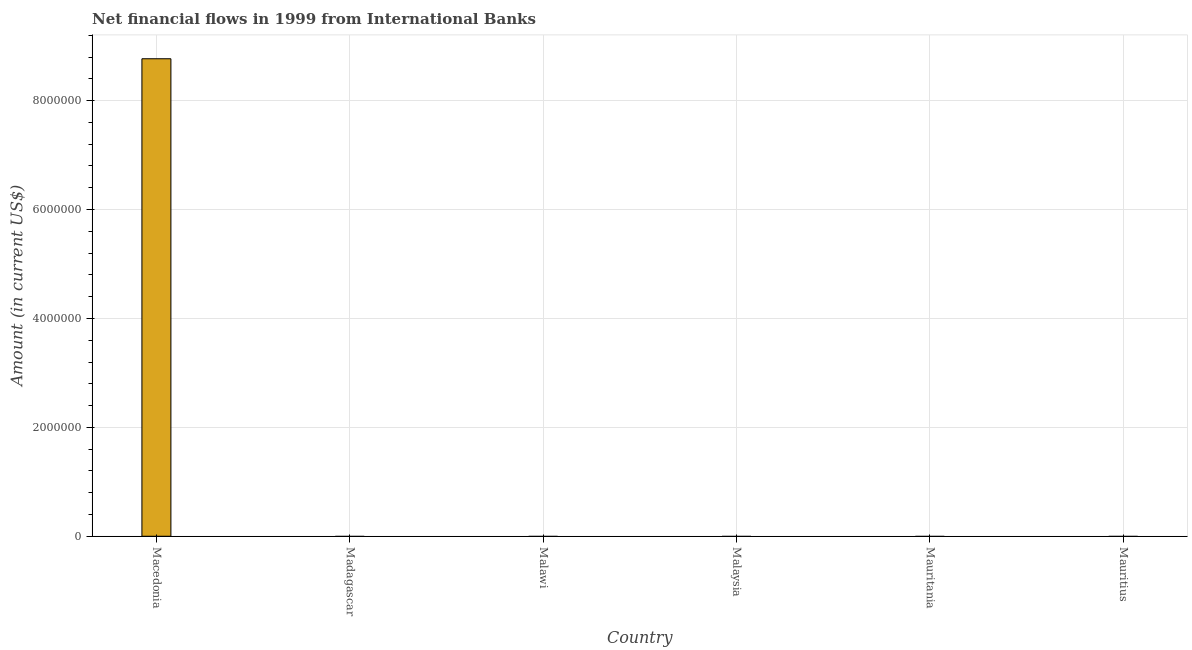What is the title of the graph?
Offer a terse response. Net financial flows in 1999 from International Banks. What is the label or title of the X-axis?
Offer a terse response. Country. Across all countries, what is the maximum net financial flows from ibrd?
Keep it short and to the point. 8.77e+06. In which country was the net financial flows from ibrd maximum?
Ensure brevity in your answer.  Macedonia. What is the sum of the net financial flows from ibrd?
Keep it short and to the point. 8.77e+06. What is the average net financial flows from ibrd per country?
Give a very brief answer. 1.46e+06. What is the difference between the highest and the lowest net financial flows from ibrd?
Ensure brevity in your answer.  8.77e+06. Are all the bars in the graph horizontal?
Provide a succinct answer. No. How many countries are there in the graph?
Offer a terse response. 6. What is the Amount (in current US$) of Macedonia?
Your answer should be compact. 8.77e+06. What is the Amount (in current US$) of Madagascar?
Your response must be concise. 0. What is the Amount (in current US$) in Malawi?
Provide a short and direct response. 0. What is the Amount (in current US$) of Malaysia?
Offer a very short reply. 0. 